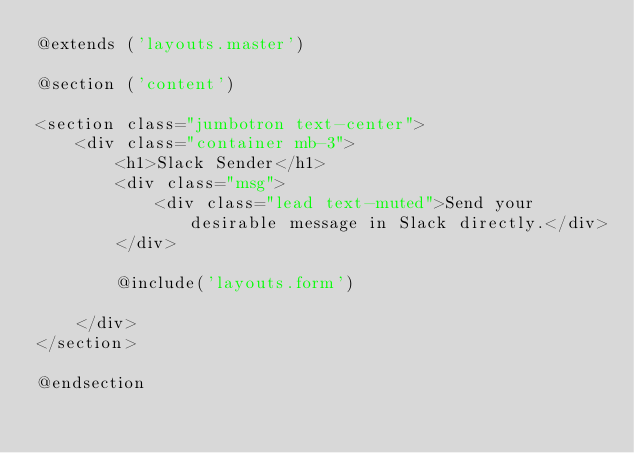Convert code to text. <code><loc_0><loc_0><loc_500><loc_500><_PHP_>@extends ('layouts.master')

@section ('content')

<section class="jumbotron text-center">
    <div class="container mb-3">
        <h1>Slack Sender</h1>
        <div class="msg">
            <div class="lead text-muted">Send your desirable message in Slack directly.</div>
        </div>

        @include('layouts.form')

    </div>
</section>

@endsection
</code> 